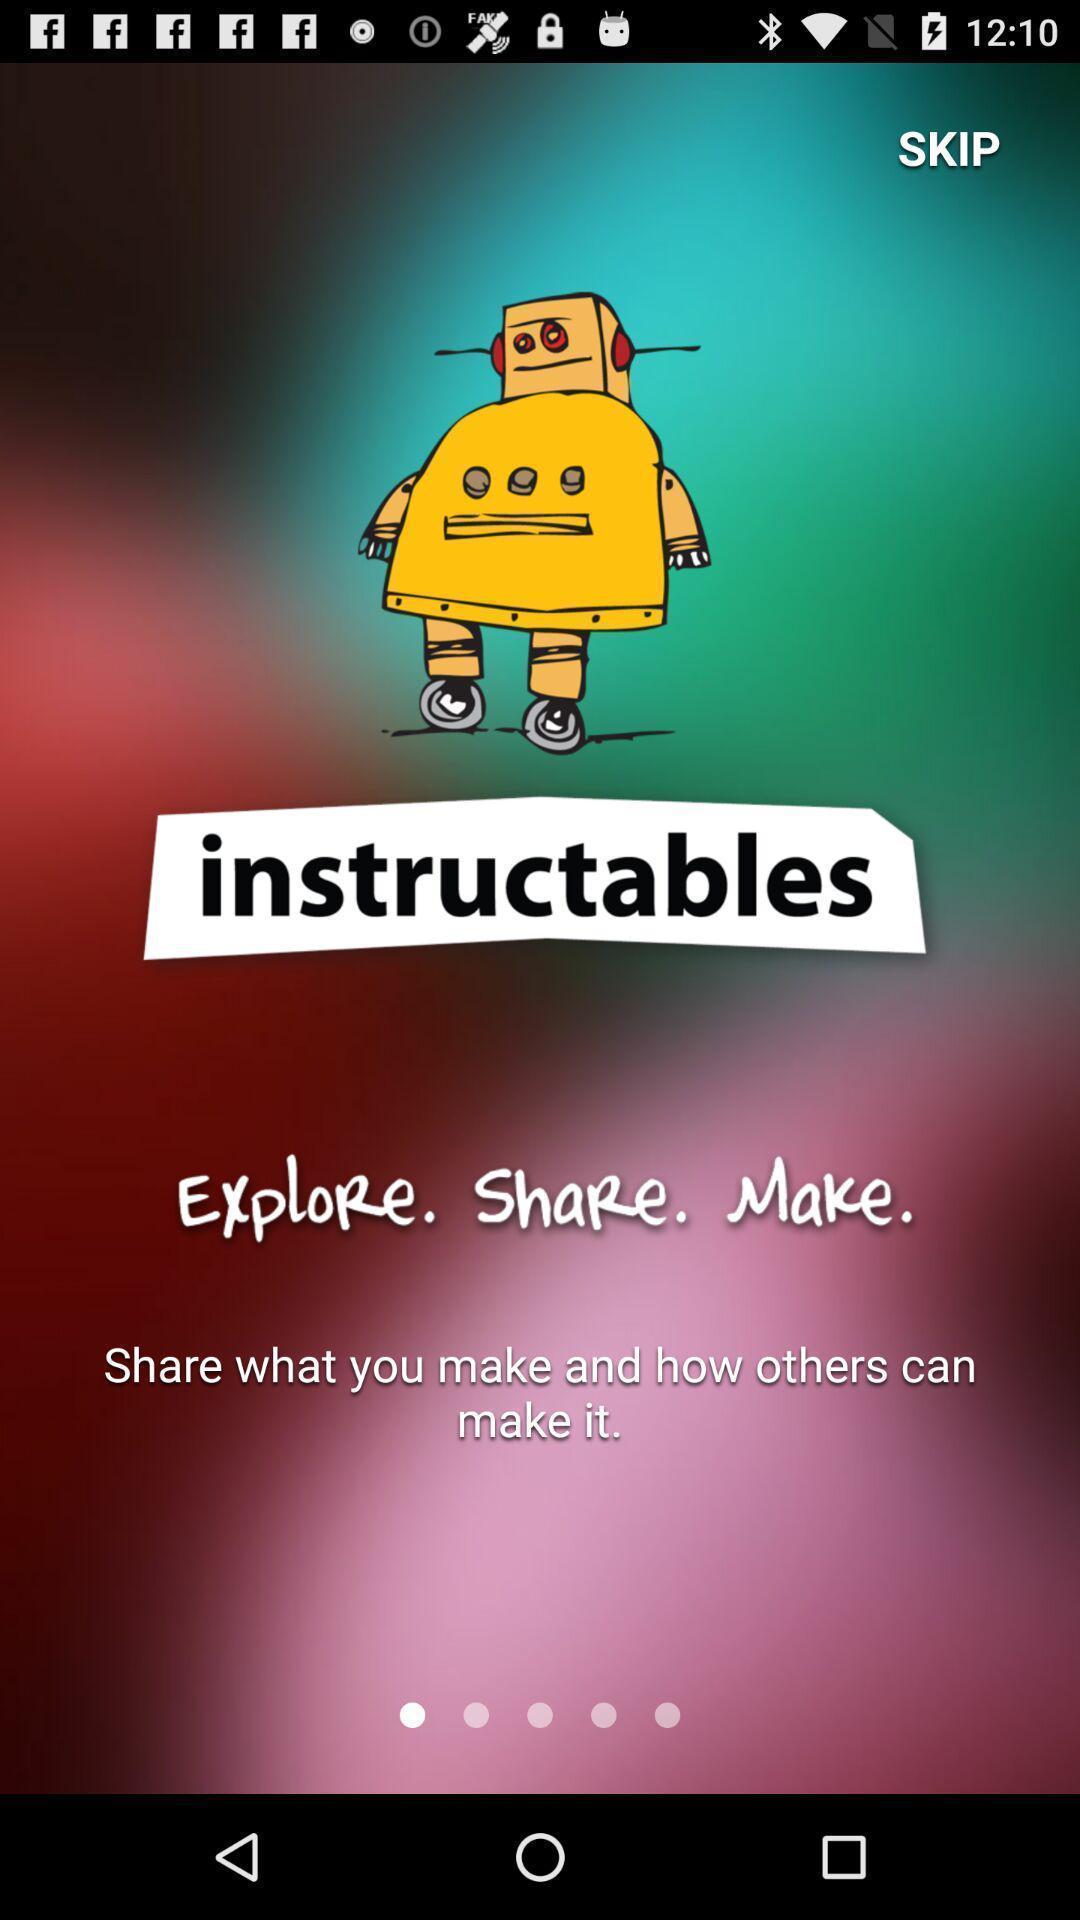Summarize the main components in this picture. Welcome page for a sharing app. 